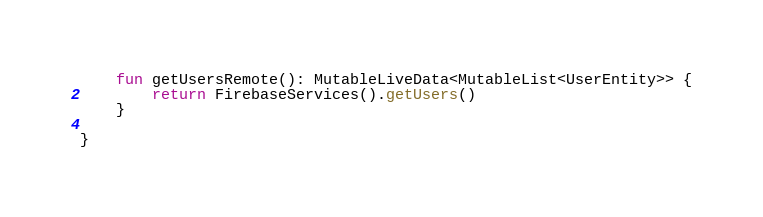Convert code to text. <code><loc_0><loc_0><loc_500><loc_500><_Kotlin_>
    fun getUsersRemote(): MutableLiveData<MutableList<UserEntity>> {
        return FirebaseServices().getUsers()
    }

}</code> 